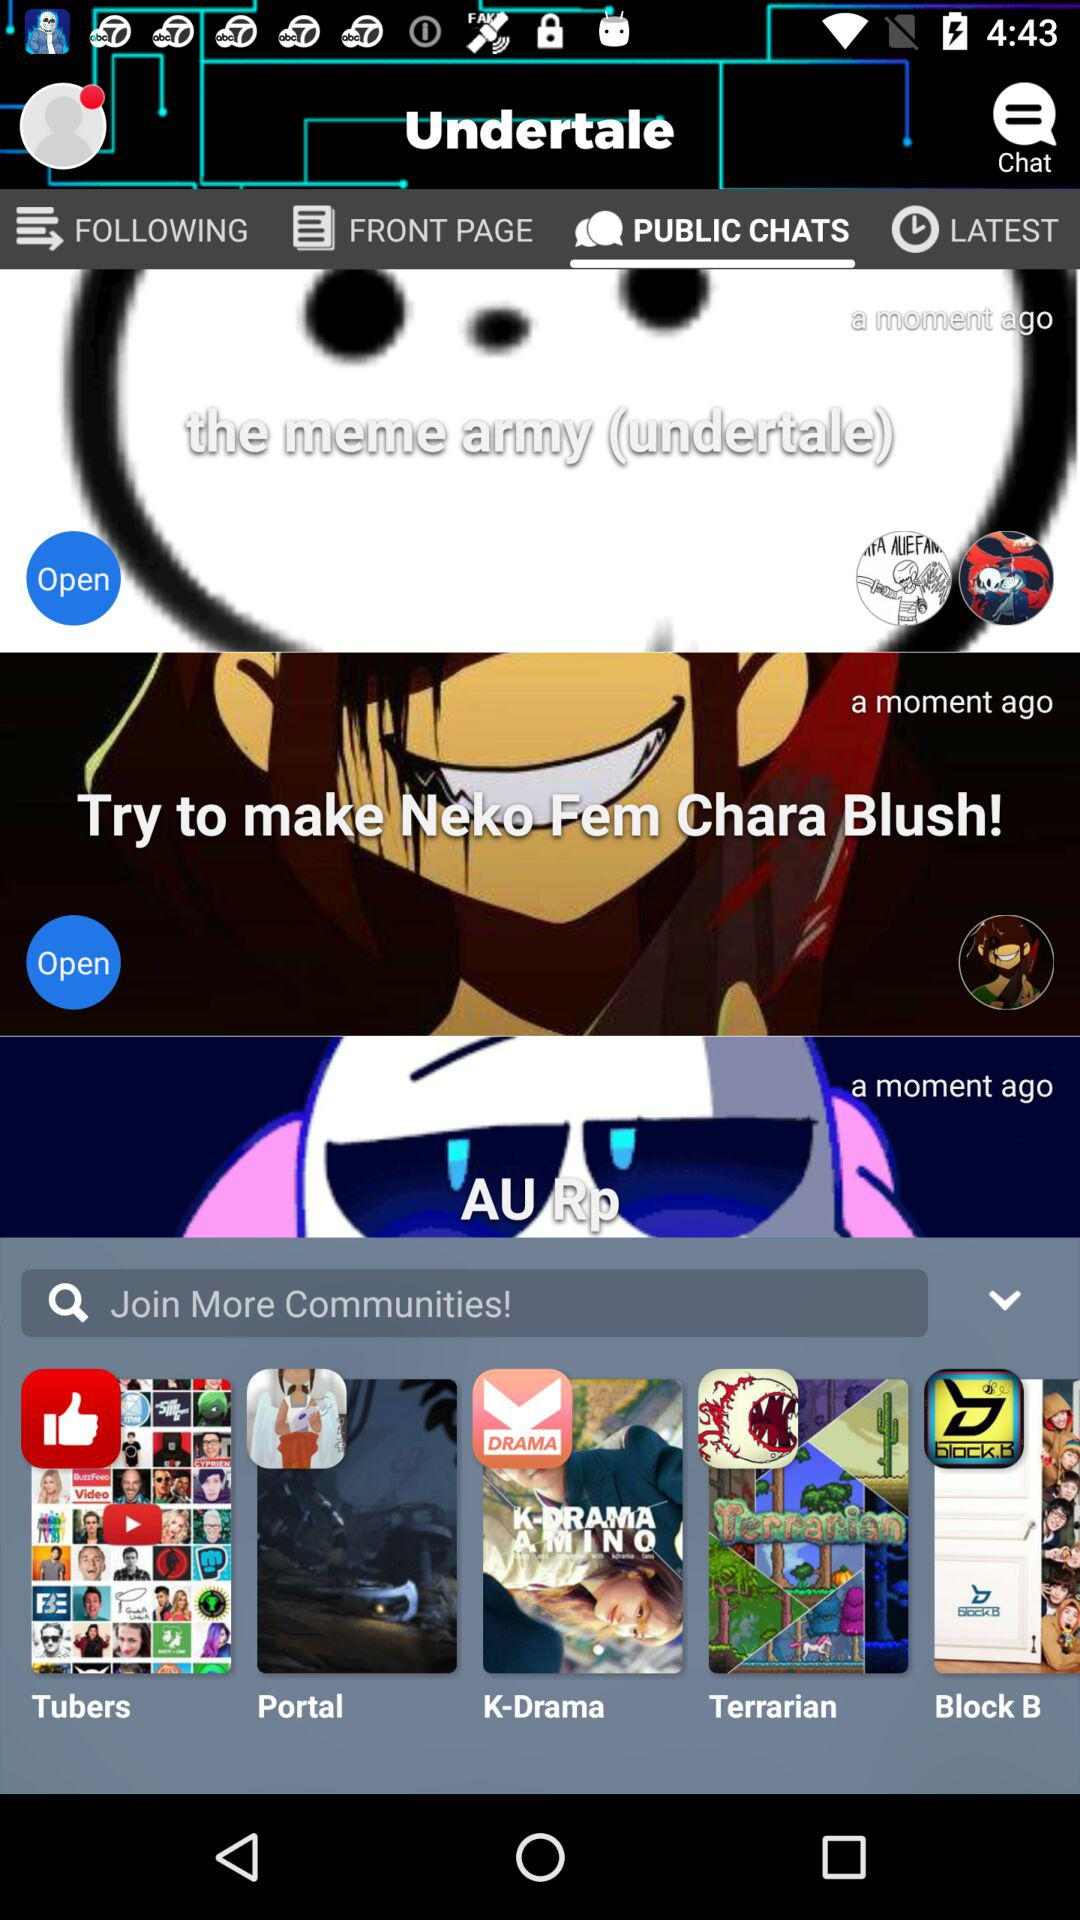Which community icon has a thumbs-up on it? The community that has a thumbs-up icon on it is "Tubers". 